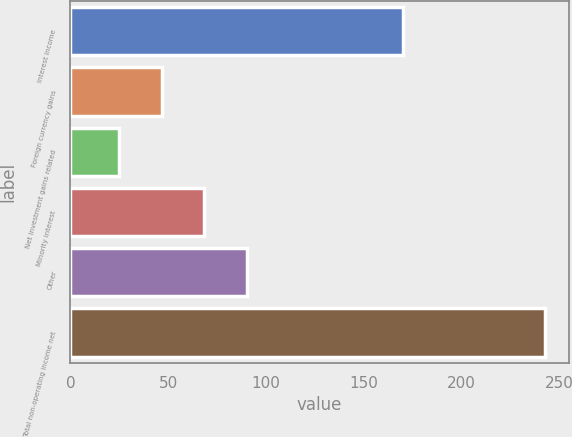Convert chart to OTSL. <chart><loc_0><loc_0><loc_500><loc_500><bar_chart><fcel>Interest income<fcel>Foreign currency gains<fcel>Net investment gains related<fcel>Minority interest<fcel>Other<fcel>Total non-operating income net<nl><fcel>170<fcel>46.8<fcel>25<fcel>68.6<fcel>90.4<fcel>243<nl></chart> 